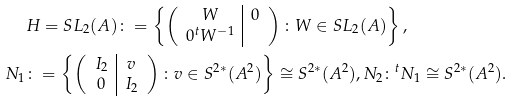<formula> <loc_0><loc_0><loc_500><loc_500>& H = S L _ { 2 } ( A ) \colon = \left \{ \left ( \begin{array} { c | c } W & 0 \\ 0 ^ { t } W ^ { - 1 } \\ \end{array} \right ) \colon W \in S L _ { 2 } ( A ) \right \} , \\ N _ { 1 } & \colon = \left \{ \left ( \begin{array} { c | c } I _ { 2 } & v \\ 0 & I _ { 2 } \end{array} \right ) \colon v \in S ^ { 2 * } ( A ^ { 2 } ) \right \} \cong S ^ { 2 * } ( A ^ { 2 } ) , N _ { 2 } \colon ^ { t } N _ { 1 } \cong S ^ { 2 * } ( A ^ { 2 } ) .</formula> 